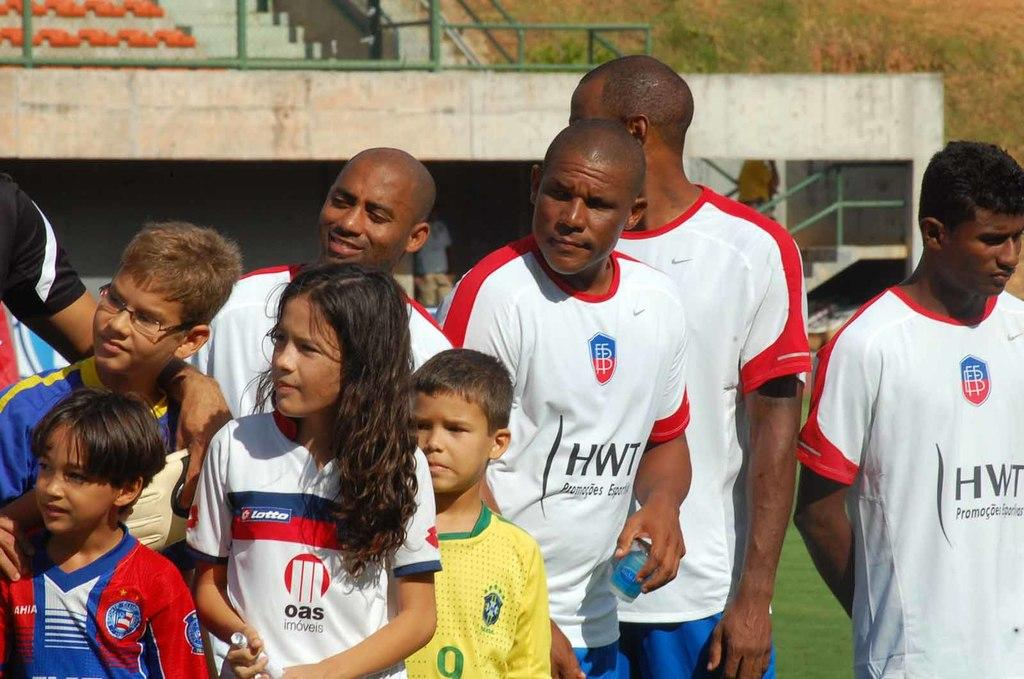<image>
Relay a brief, clear account of the picture shown. a few players and one with HWT on their shirt 